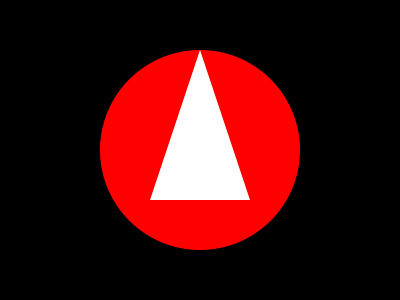Analyze the symbolism in this minimalist movie poster design. What genre and themes might this poster represent, and how does the use of color and shape contribute to this interpretation? To interpret the symbolism in this minimalist movie poster design, we need to consider the following elements:

1. Shapes:
   - Circle: Represents wholeness, infinity, or cyclical nature
   - Triangle: Often symbolizes conflict, tension, or change

2. Colors:
   - Black background: Suggests mystery, darkness, or the unknown
   - Red circle: Can represent passion, danger, or urgency
   - White triangle: Might symbolize purity, innocence, or a contrasting force

3. Composition:
   - The triangle is superimposed on the circle, creating a sense of intrusion or disruption

4. Genre interpretation:
   - The combination of these elements suggests a thriller or psychological horror film

5. Thematic analysis:
   - The contrast between the circle and triangle could represent:
     a) The battle between good and evil
     b) An outside force disrupting a stable environment
     c) The complexity of human nature (red passion vs. white purity)

6. Minimalist approach:
   - The simplicity of the design allows for multiple interpretations, engaging the viewer's imagination

7. Filmmaker perspective:
   - As a screenwriter and filmmaker, consider how this visual metaphor might translate to narrative elements or character arcs in a script

The poster's design effectively uses basic geometric shapes and a limited color palette to create a visually striking and symbolically rich image that hints at the film's content without revealing too much.
Answer: Psychological thriller; themes of disruption and internal conflict; color and shape contrast to create tension and symbolize opposing forces. 